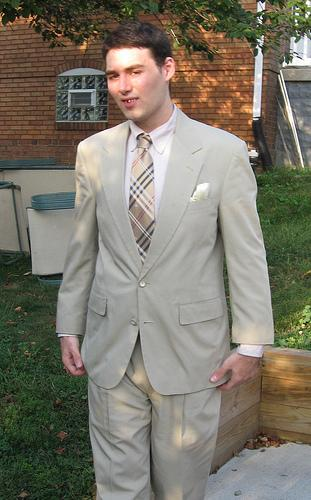In the context of the image, what is the intersection between different objects? Objects such as the man's attire, the retaining wall, the building, and the leaves all interact in a way that creates a scene of a formally dressed man in an urban environment with signs of nature. Deduce the purpose of this image in the context of complex reasoning. The image aims to represent a scenario where a formally dressed man is found in an urban environment with elements of nature, where the objects in the image can interplay in multiple aspects such as attire, background, and environmental features. State what the young man's attire reveals about his context. The young man is likely dressed for a formal or professional event, as indicated by his business suit, tie, white dress shirt, and light-colored blazer. What is the main object of attention in the image and what is he wearing? A young man in a tan suit, with a striped tie, a shirt, and a white handkerchief in his pocket. What type of wall is next to the man and what is in the corner of the wall?  There is a wooden retainer wall next to the man and some dead leaves in the corner of the wall. Explain the nature of the building near the man and its prominent features. The building is a red brick structure, with an arched window, a white and black metal gutter spout, an exterior window air conditioner, and glass block in the window. Evaluate the image's quality in terms of its subjects and their features. The image is of good quality, as it captures many details like the man's attire (suit, tie, handkerchief), the wooden retainer wall, dead leaves, the red brick building, and the gutter system. Estimate the number of objects with leaves in the image and briefly describe their locations. There are three objects with leaves: 1) pile of dead leaves on the cement slab, 2) brown leaves in grass, and 3) brown leaves in the corner of the paved patch of ground. Analyze the image's aspects that evoke sentiment or convey a certain mood. The young man dressed in a formal attire amidst an urban setting with elements of nature, such as the wooden retainer wall and the leaves, gives a sense of contrasting yet harmonious moods between professionalism and natural beauty. Briefly describe the situation of the man in relation to his surroundings. A young man wearing a business suit and tie, standing near a retaining wall, with leaves in the corner of the wall and a gutter system on a nearby building. 